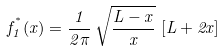Convert formula to latex. <formula><loc_0><loc_0><loc_500><loc_500>f _ { 1 } ^ { ^ { * } } ( x ) = \frac { 1 } { 2 \pi } \, \sqrt { \frac { L - x } { x } } \, \left [ L + 2 x \right ]</formula> 